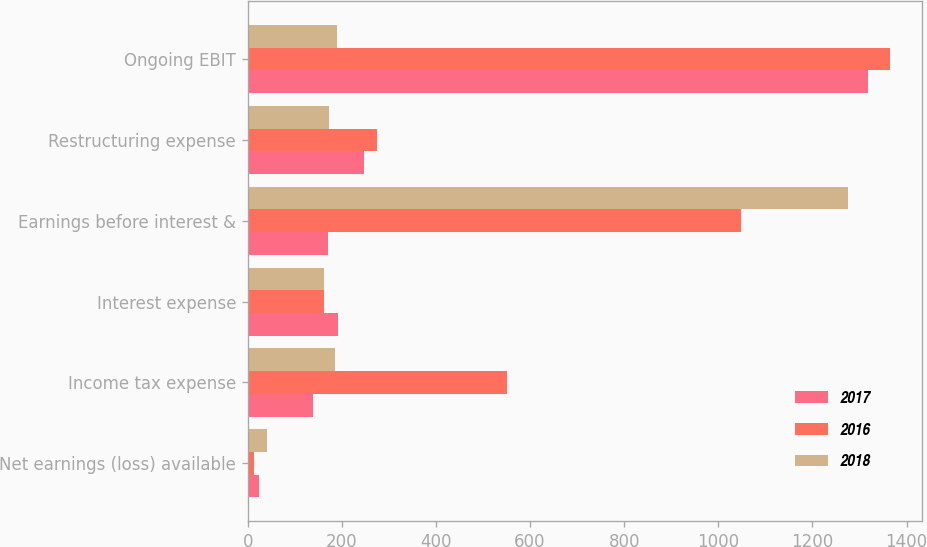<chart> <loc_0><loc_0><loc_500><loc_500><stacked_bar_chart><ecel><fcel>Net earnings (loss) available<fcel>Income tax expense<fcel>Interest expense<fcel>Earnings before interest &<fcel>Restructuring expense<fcel>Ongoing EBIT<nl><fcel>2017<fcel>24<fcel>138<fcel>192<fcel>171<fcel>247<fcel>1319<nl><fcel>2016<fcel>13<fcel>550<fcel>162<fcel>1049<fcel>275<fcel>1364<nl><fcel>2018<fcel>40<fcel>186<fcel>161<fcel>1275<fcel>173<fcel>189<nl></chart> 